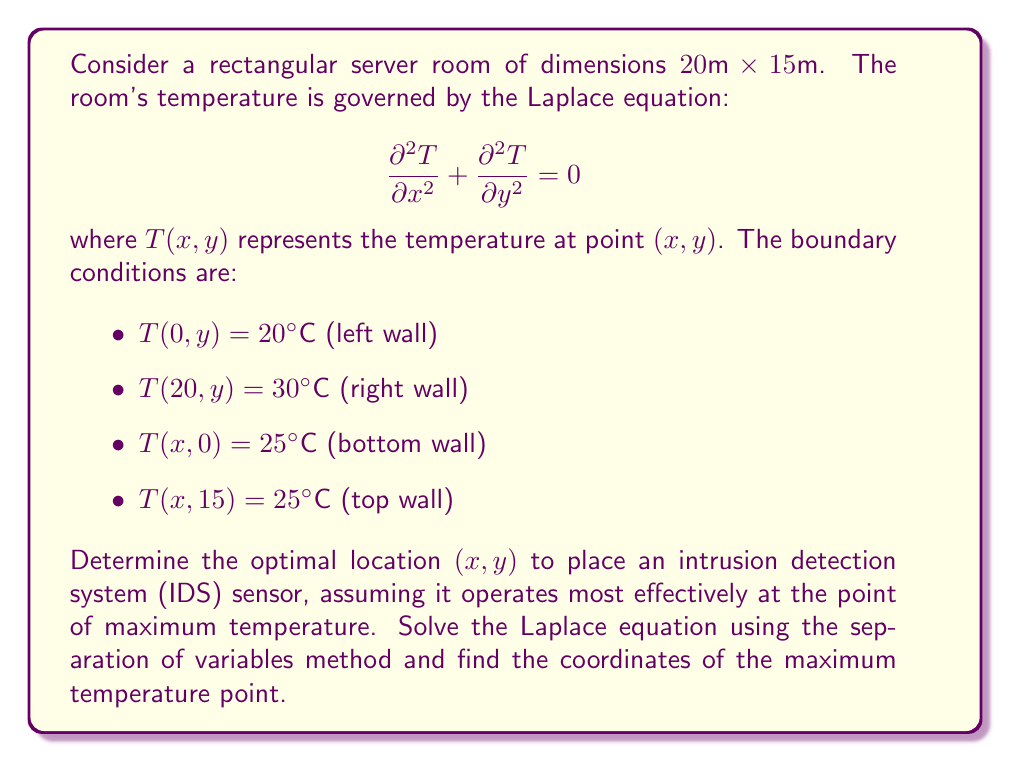Could you help me with this problem? To solve this problem, we'll follow these steps:

1) Apply the separation of variables method to solve the Laplace equation.
2) Use the boundary conditions to determine the coefficients.
3) Find the general solution.
4) Locate the point of maximum temperature.

Step 1: Separation of Variables

Let $T(x,y) = X(x)Y(y)$. Substituting into the Laplace equation:

$$X''Y + XY'' = 0$$
$$\frac{X''}{X} = -\frac{Y''}{Y} = -\lambda^2$$

This gives us two ordinary differential equations:
$$X'' + \lambda^2 X = 0$$
$$Y'' - \lambda^2 Y = 0$$

The general solutions are:
$$X(x) = A \cos(\lambda x) + B \sin(\lambda x)$$
$$Y(y) = C e^{\lambda y} + D e^{-\lambda y}$$

Step 2: Apply Boundary Conditions

From the left and right wall conditions:
$$T(0,y) = 20 \implies X(0) = 20$$
$$T(20,y) = 30 \implies X(20) = 30$$

This gives us:
$$X(x) = 20 + \frac{x}{2}$$

From the top and bottom wall conditions:
$$T(x,0) = T(x,15) = 25$$

This implies $Y(y)$ must be constant, so $\lambda = 0$.

Step 3: General Solution

The general solution is therefore:

$$T(x,y) = 20 + \frac{x}{2}$$

Step 4: Maximum Temperature Point

The temperature increases linearly with $x$ and is independent of $y$. The maximum temperature occurs at the right wall where $x = 20$:

$$(x_{max}, y_{max}) = (20, y) \text{ for any } y \in [0,15]$$

The maximum temperature is 30°C, occurring along the entire right wall.
Answer: The optimal location to place the IDS sensor is at $(x,y) = (20, y)$ for any $y \in [0,15]$, where the temperature reaches its maximum of 30°C. 